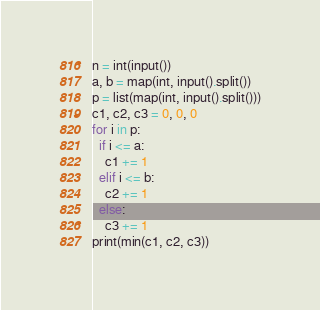Convert code to text. <code><loc_0><loc_0><loc_500><loc_500><_Python_>n = int(input())
a, b = map(int, input().split())
p = list(map(int, input().split()))
c1, c2, c3 = 0, 0, 0
for i in p:
  if i <= a:
    c1 += 1
  elif i <= b:
    c2 += 1
  else:
    c3 += 1
print(min(c1, c2, c3))</code> 